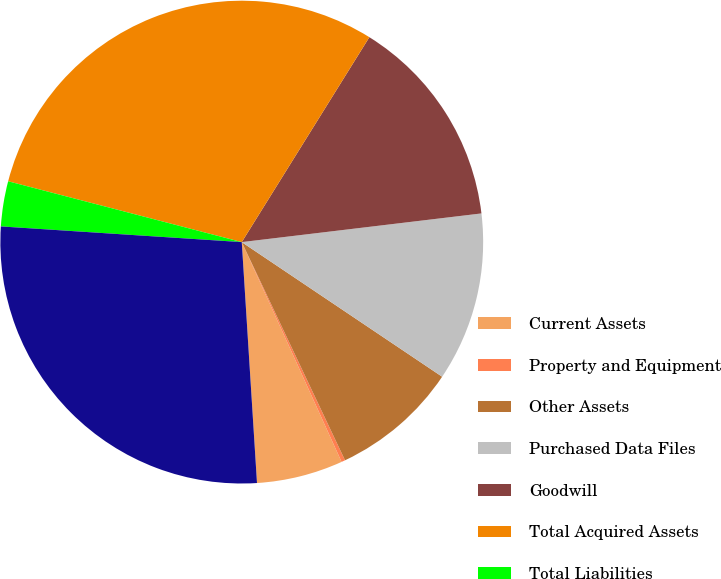Convert chart to OTSL. <chart><loc_0><loc_0><loc_500><loc_500><pie_chart><fcel>Current Assets<fcel>Property and Equipment<fcel>Other Assets<fcel>Purchased Data Files<fcel>Goodwill<fcel>Total Acquired Assets<fcel>Total Liabilities<fcel>Net Assets Acquired<nl><fcel>5.78%<fcel>0.25%<fcel>8.55%<fcel>11.31%<fcel>14.24%<fcel>29.81%<fcel>3.02%<fcel>27.04%<nl></chart> 